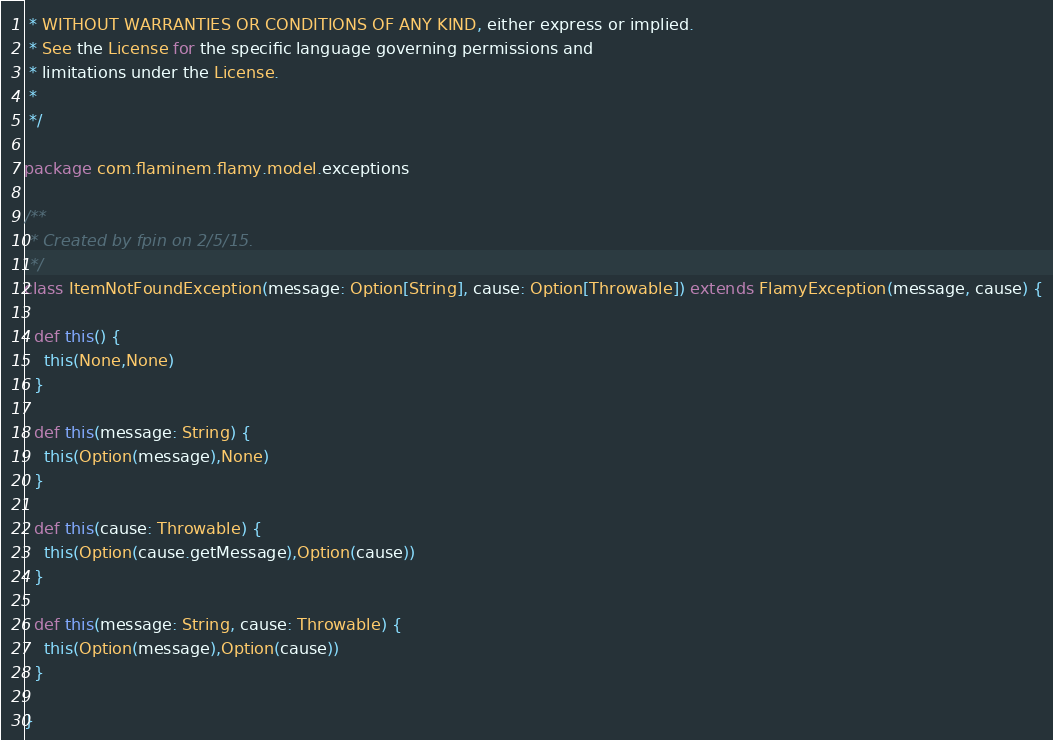<code> <loc_0><loc_0><loc_500><loc_500><_Scala_> * WITHOUT WARRANTIES OR CONDITIONS OF ANY KIND, either express or implied.
 * See the License for the specific language governing permissions and
 * limitations under the License.
 *
 */

package com.flaminem.flamy.model.exceptions

/**
 * Created by fpin on 2/5/15.
 */
class ItemNotFoundException(message: Option[String], cause: Option[Throwable]) extends FlamyException(message, cause) {

  def this() {
    this(None,None)
  }

  def this(message: String) {
    this(Option(message),None)
  }

  def this(cause: Throwable) {
    this(Option(cause.getMessage),Option(cause))
  }

  def this(message: String, cause: Throwable) {
    this(Option(message),Option(cause))
  }

}
</code> 